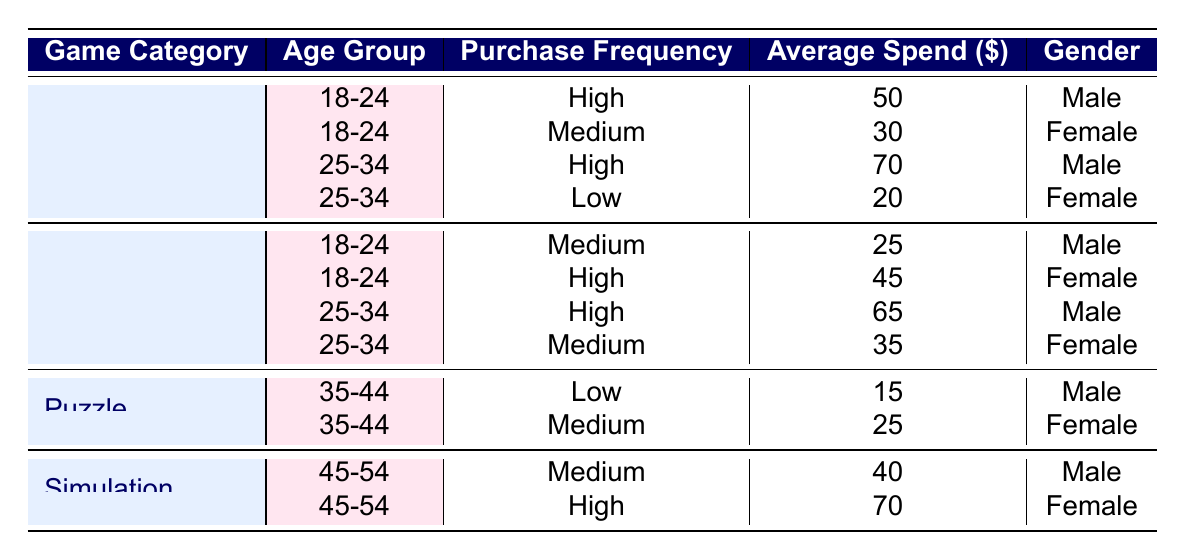What is the average spend for Females in the "Battle Royale" category? The rows for "Battle Royale" and "Female" gender are: (45) from age 18-24 and (35) from age 25-34. Adding these gives 45 + 35 = 80. There are 2 data points, hence the average spend is 80 / 2 = 40.
Answer: 40 Which game category has the highest average spend overall? To find this, we take the average spends per category: Mobile RPG: (50 + 30 + 70 + 20) / 4 = 42.5, Battle Royale: (25 + 45 + 65 + 35) / 4 = 42.5, Puzzle: (15 + 25) / 2 = 20, Simulation: (40 + 70) / 2 = 55. Simulation has the highest average spend of 55.
Answer: Simulation Is there a "Low" purchase frequency in the "Simulation" category? Looking at the table, "Simulation" has only "Medium" and "High" purchase frequencies. Therefore, there is no entry for "Low".
Answer: No What is the total average spend for Males aged 25-34 across all game categories? For Males aged 25-34, we have two entries: Mobile RPG (70) and Battle Royale (65). Therefore, the total average spend is 70 + 65 = 135, and there are 2 data points, so the average is 135 / 2 = 67.5.
Answer: 67.5 Are there any Females who spend more than 60 in any game category? In the table, the only Female entry with an average spend above 60 is in the Simulation category with an average spend of 70. Therefore, the answer is yes.
Answer: Yes What is the combined average spend for Males in "Mobile RPG" and "Puzzle"? Males spend 50 and 70 in "Mobile RPG" and 15 in "Puzzle". Summing gives 50 + 70 + 15 = 135. There are 3 data points, thus average = 135 / 3 = 45.
Answer: 45 Which age group has the lowest average spend in the "Puzzle" category? In the Puzzle category, the spends are: Male aged 35-44 (15) and Female aged 35-44 (25). The lowest average is Male with 15.
Answer: Male aged 35-44 How many categories have a "High" purchase frequency that is specific to the 18-24 age group for Males? The "Battle Royale" category has a "High" frequency at 18-24 age group for Females, but there is no high frequency for Males in that age group. Only Mobile RPG (50) is for Males. Therefore, only 1 category.
Answer: 1 